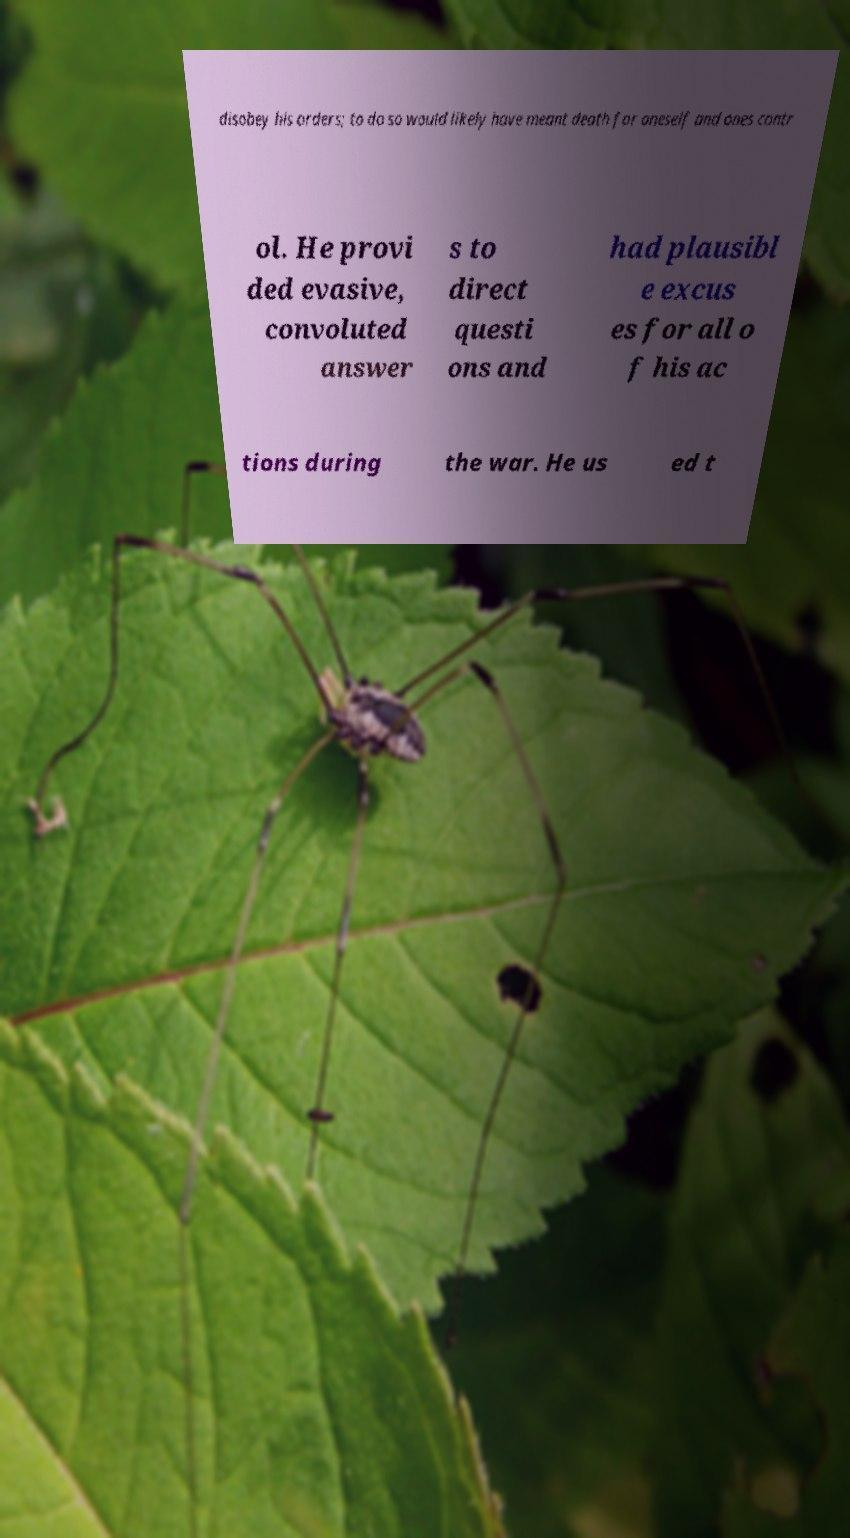Can you accurately transcribe the text from the provided image for me? disobey his orders; to do so would likely have meant death for oneself and ones contr ol. He provi ded evasive, convoluted answer s to direct questi ons and had plausibl e excus es for all o f his ac tions during the war. He us ed t 